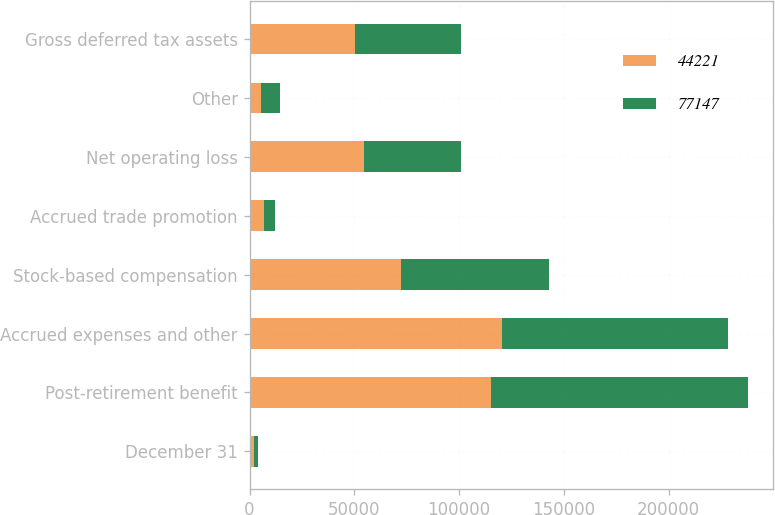Convert chart. <chart><loc_0><loc_0><loc_500><loc_500><stacked_bar_chart><ecel><fcel>December 31<fcel>Post-retirement benefit<fcel>Accrued expenses and other<fcel>Stock-based compensation<fcel>Accrued trade promotion<fcel>Net operating loss<fcel>Other<fcel>Gross deferred tax assets<nl><fcel>44221<fcel>2010<fcel>115068<fcel>120258<fcel>72498<fcel>6902<fcel>54649<fcel>5598<fcel>50472.5<nl><fcel>77147<fcel>2009<fcel>122815<fcel>108181<fcel>70224<fcel>5282<fcel>46296<fcel>9075<fcel>50472.5<nl></chart> 